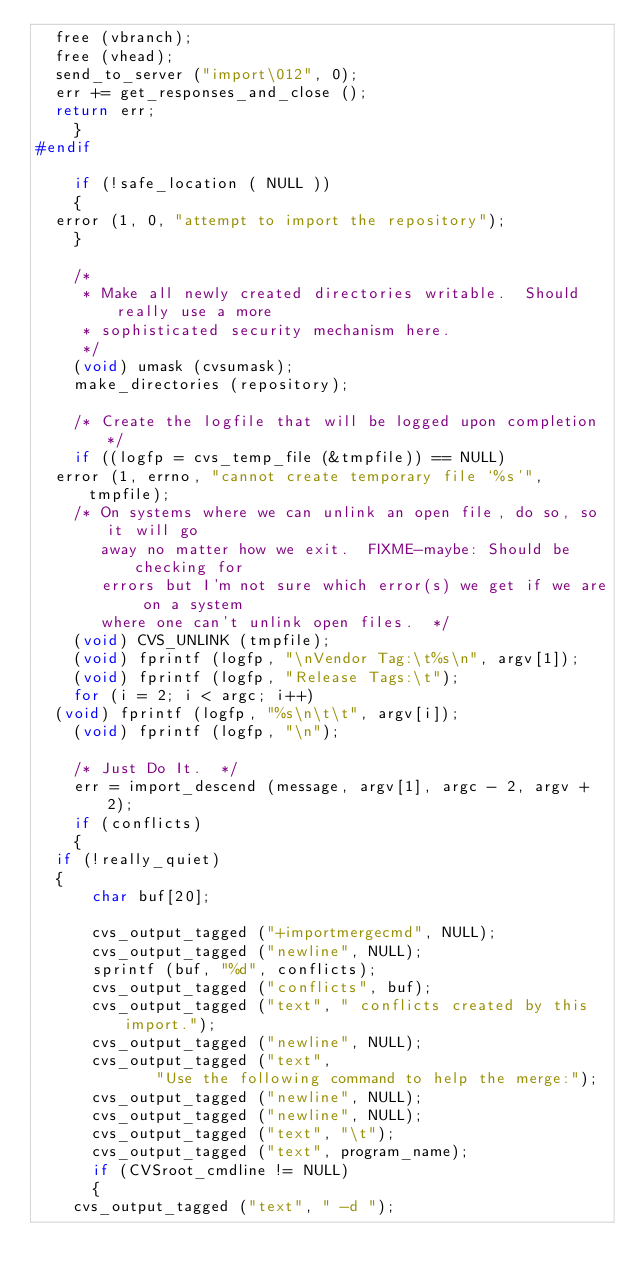Convert code to text. <code><loc_0><loc_0><loc_500><loc_500><_C_>	free (vbranch);
	free (vhead);
	send_to_server ("import\012", 0);
	err += get_responses_and_close ();
	return err;
    }
#endif

    if (!safe_location ( NULL ))
    {
	error (1, 0, "attempt to import the repository");
    }

    /*
     * Make all newly created directories writable.  Should really use a more
     * sophisticated security mechanism here.
     */
    (void) umask (cvsumask);
    make_directories (repository);

    /* Create the logfile that will be logged upon completion */
    if ((logfp = cvs_temp_file (&tmpfile)) == NULL)
	error (1, errno, "cannot create temporary file `%s'", tmpfile);
    /* On systems where we can unlink an open file, do so, so it will go
       away no matter how we exit.  FIXME-maybe: Should be checking for
       errors but I'm not sure which error(s) we get if we are on a system
       where one can't unlink open files.  */
    (void) CVS_UNLINK (tmpfile);
    (void) fprintf (logfp, "\nVendor Tag:\t%s\n", argv[1]);
    (void) fprintf (logfp, "Release Tags:\t");
    for (i = 2; i < argc; i++)
	(void) fprintf (logfp, "%s\n\t\t", argv[i]);
    (void) fprintf (logfp, "\n");

    /* Just Do It.  */
    err = import_descend (message, argv[1], argc - 2, argv + 2);
    if (conflicts)
    {
	if (!really_quiet)
	{
	    char buf[20];

	    cvs_output_tagged ("+importmergecmd", NULL);
	    cvs_output_tagged ("newline", NULL);
	    sprintf (buf, "%d", conflicts);
	    cvs_output_tagged ("conflicts", buf);
	    cvs_output_tagged ("text", " conflicts created by this import.");
	    cvs_output_tagged ("newline", NULL);
	    cvs_output_tagged ("text",
			       "Use the following command to help the merge:");
	    cvs_output_tagged ("newline", NULL);
	    cvs_output_tagged ("newline", NULL);
	    cvs_output_tagged ("text", "\t");
	    cvs_output_tagged ("text", program_name);
	    if (CVSroot_cmdline != NULL)
	    {
		cvs_output_tagged ("text", " -d ");</code> 